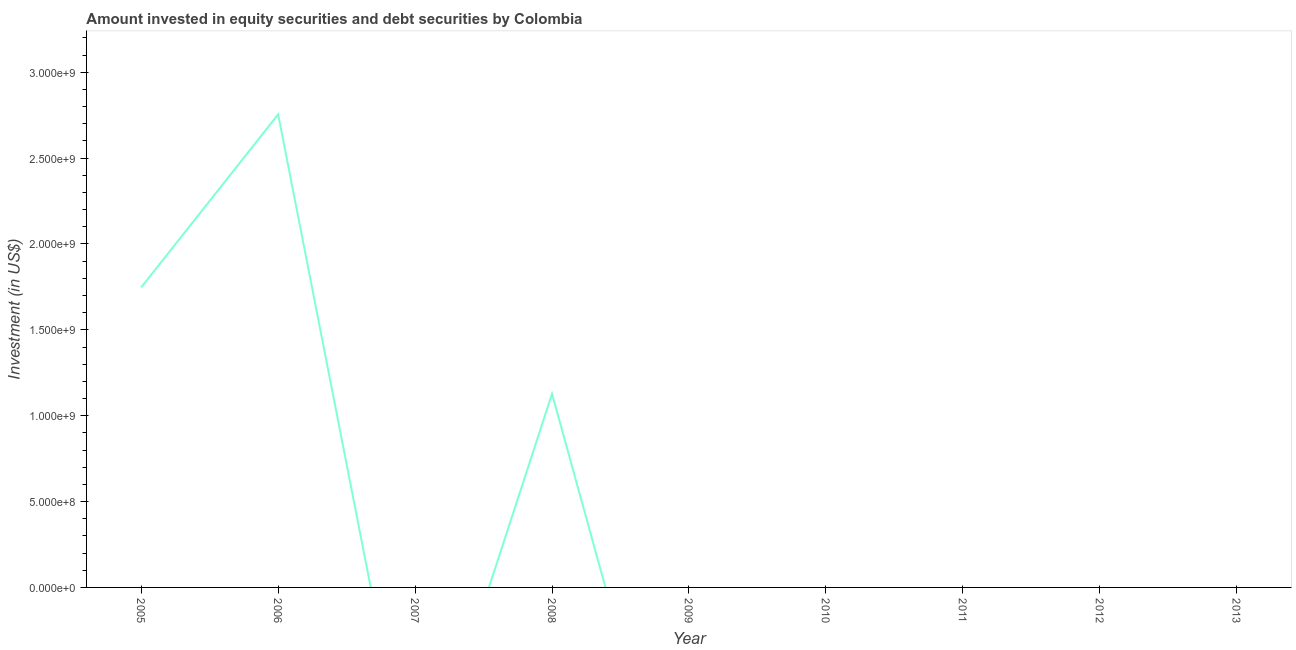What is the portfolio investment in 2006?
Make the answer very short. 2.75e+09. Across all years, what is the maximum portfolio investment?
Your answer should be very brief. 2.75e+09. Across all years, what is the minimum portfolio investment?
Provide a short and direct response. 0. In which year was the portfolio investment maximum?
Your answer should be compact. 2006. What is the sum of the portfolio investment?
Provide a succinct answer. 5.63e+09. What is the difference between the portfolio investment in 2005 and 2006?
Provide a short and direct response. -1.01e+09. What is the average portfolio investment per year?
Offer a terse response. 6.26e+08. What is the median portfolio investment?
Offer a very short reply. 0. What is the difference between the highest and the second highest portfolio investment?
Offer a terse response. 1.01e+09. What is the difference between the highest and the lowest portfolio investment?
Provide a short and direct response. 2.75e+09. Does the portfolio investment monotonically increase over the years?
Offer a very short reply. No. What is the difference between two consecutive major ticks on the Y-axis?
Keep it short and to the point. 5.00e+08. Are the values on the major ticks of Y-axis written in scientific E-notation?
Your answer should be very brief. Yes. Does the graph contain any zero values?
Provide a succinct answer. Yes. Does the graph contain grids?
Your answer should be very brief. No. What is the title of the graph?
Provide a short and direct response. Amount invested in equity securities and debt securities by Colombia. What is the label or title of the X-axis?
Your answer should be very brief. Year. What is the label or title of the Y-axis?
Give a very brief answer. Investment (in US$). What is the Investment (in US$) of 2005?
Ensure brevity in your answer.  1.75e+09. What is the Investment (in US$) in 2006?
Ensure brevity in your answer.  2.75e+09. What is the Investment (in US$) of 2008?
Make the answer very short. 1.13e+09. What is the Investment (in US$) in 2010?
Your answer should be very brief. 0. What is the Investment (in US$) of 2013?
Offer a very short reply. 0. What is the difference between the Investment (in US$) in 2005 and 2006?
Your answer should be compact. -1.01e+09. What is the difference between the Investment (in US$) in 2005 and 2008?
Make the answer very short. 6.19e+08. What is the difference between the Investment (in US$) in 2006 and 2008?
Make the answer very short. 1.63e+09. What is the ratio of the Investment (in US$) in 2005 to that in 2006?
Give a very brief answer. 0.63. What is the ratio of the Investment (in US$) in 2005 to that in 2008?
Ensure brevity in your answer.  1.55. What is the ratio of the Investment (in US$) in 2006 to that in 2008?
Provide a short and direct response. 2.44. 